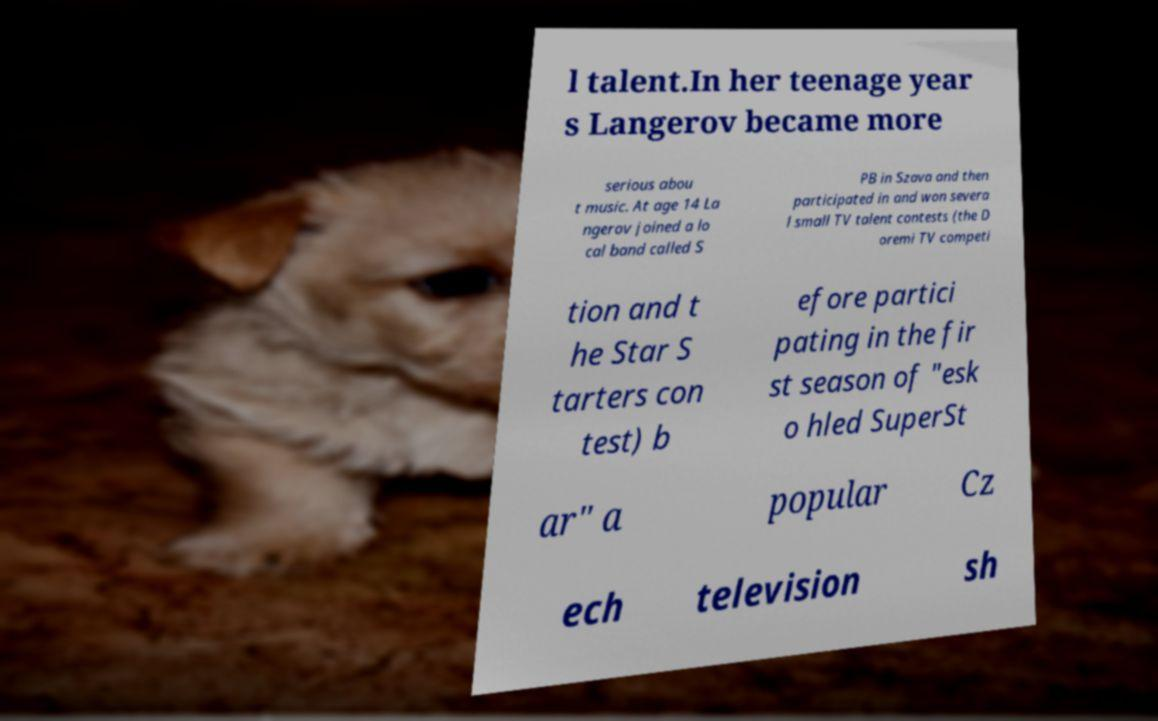Could you extract and type out the text from this image? l talent.In her teenage year s Langerov became more serious abou t music. At age 14 La ngerov joined a lo cal band called S PB in Szava and then participated in and won severa l small TV talent contests (the D oremi TV competi tion and t he Star S tarters con test) b efore partici pating in the fir st season of "esk o hled SuperSt ar" a popular Cz ech television sh 